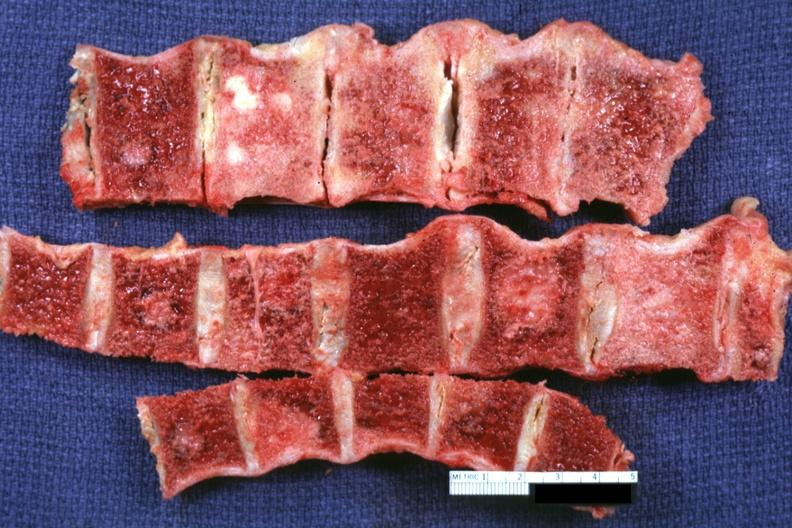how is several segments of vertebral column with easily seen lesions primary prostate adenocarcinoma?
Answer the question using a single word or phrase. Metastatic 